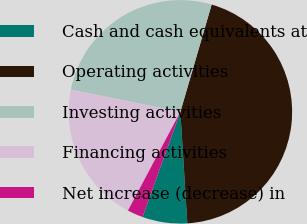Convert chart to OTSL. <chart><loc_0><loc_0><loc_500><loc_500><pie_chart><fcel>Cash and cash equivalents at<fcel>Operating activities<fcel>Investing activities<fcel>Financing activities<fcel>Net increase (decrease) in<nl><fcel>6.49%<fcel>44.49%<fcel>26.33%<fcel>20.42%<fcel>2.27%<nl></chart> 